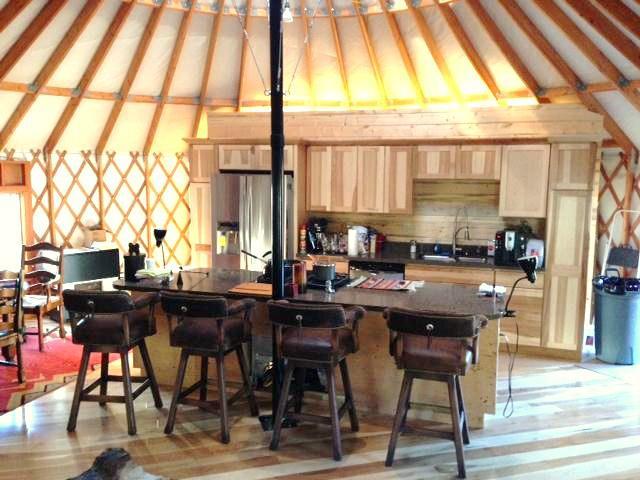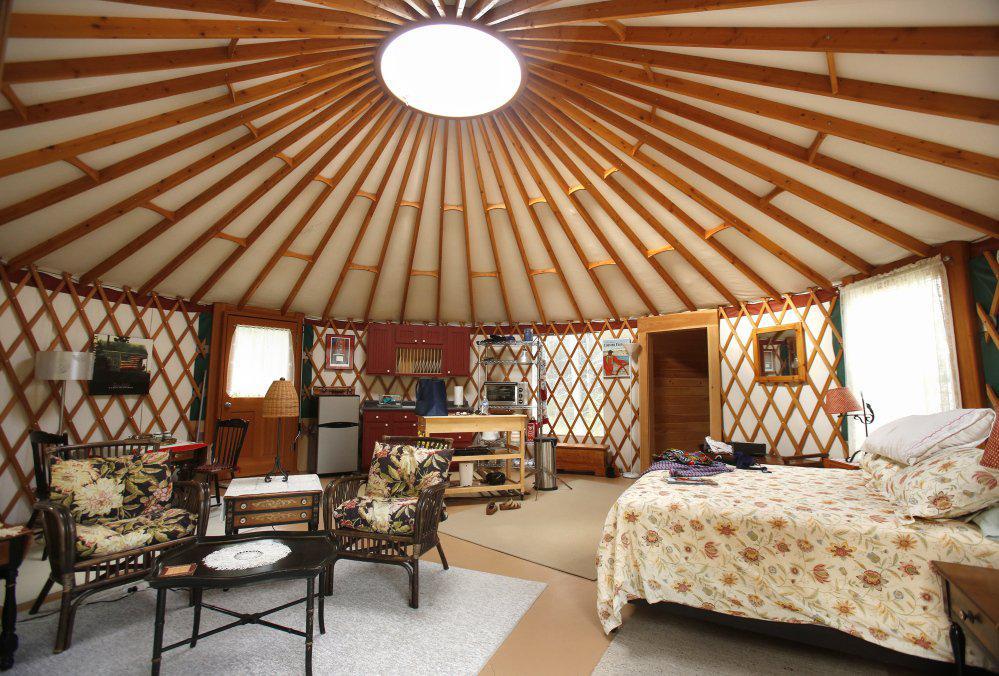The first image is the image on the left, the second image is the image on the right. Given the left and right images, does the statement "One of the images is of a bedroom." hold true? Answer yes or no. Yes. 